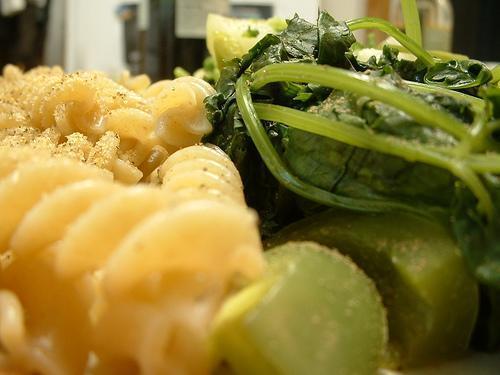How many people are sitting?
Give a very brief answer. 0. 